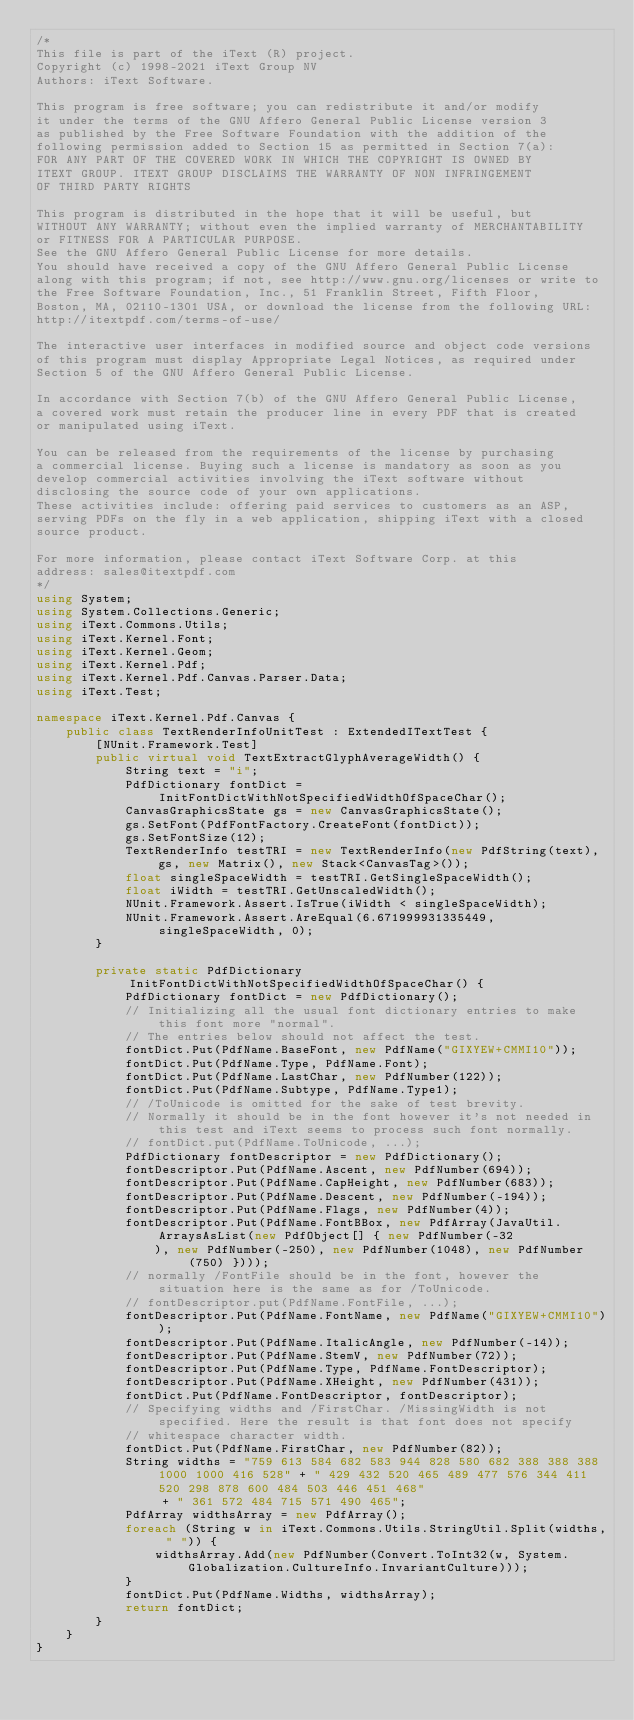<code> <loc_0><loc_0><loc_500><loc_500><_C#_>/*
This file is part of the iText (R) project.
Copyright (c) 1998-2021 iText Group NV
Authors: iText Software.

This program is free software; you can redistribute it and/or modify
it under the terms of the GNU Affero General Public License version 3
as published by the Free Software Foundation with the addition of the
following permission added to Section 15 as permitted in Section 7(a):
FOR ANY PART OF THE COVERED WORK IN WHICH THE COPYRIGHT IS OWNED BY
ITEXT GROUP. ITEXT GROUP DISCLAIMS THE WARRANTY OF NON INFRINGEMENT
OF THIRD PARTY RIGHTS

This program is distributed in the hope that it will be useful, but
WITHOUT ANY WARRANTY; without even the implied warranty of MERCHANTABILITY
or FITNESS FOR A PARTICULAR PURPOSE.
See the GNU Affero General Public License for more details.
You should have received a copy of the GNU Affero General Public License
along with this program; if not, see http://www.gnu.org/licenses or write to
the Free Software Foundation, Inc., 51 Franklin Street, Fifth Floor,
Boston, MA, 02110-1301 USA, or download the license from the following URL:
http://itextpdf.com/terms-of-use/

The interactive user interfaces in modified source and object code versions
of this program must display Appropriate Legal Notices, as required under
Section 5 of the GNU Affero General Public License.

In accordance with Section 7(b) of the GNU Affero General Public License,
a covered work must retain the producer line in every PDF that is created
or manipulated using iText.

You can be released from the requirements of the license by purchasing
a commercial license. Buying such a license is mandatory as soon as you
develop commercial activities involving the iText software without
disclosing the source code of your own applications.
These activities include: offering paid services to customers as an ASP,
serving PDFs on the fly in a web application, shipping iText with a closed
source product.

For more information, please contact iText Software Corp. at this
address: sales@itextpdf.com
*/
using System;
using System.Collections.Generic;
using iText.Commons.Utils;
using iText.Kernel.Font;
using iText.Kernel.Geom;
using iText.Kernel.Pdf;
using iText.Kernel.Pdf.Canvas.Parser.Data;
using iText.Test;

namespace iText.Kernel.Pdf.Canvas {
    public class TextRenderInfoUnitTest : ExtendedITextTest {
        [NUnit.Framework.Test]
        public virtual void TextExtractGlyphAverageWidth() {
            String text = "i";
            PdfDictionary fontDict = InitFontDictWithNotSpecifiedWidthOfSpaceChar();
            CanvasGraphicsState gs = new CanvasGraphicsState();
            gs.SetFont(PdfFontFactory.CreateFont(fontDict));
            gs.SetFontSize(12);
            TextRenderInfo testTRI = new TextRenderInfo(new PdfString(text), gs, new Matrix(), new Stack<CanvasTag>());
            float singleSpaceWidth = testTRI.GetSingleSpaceWidth();
            float iWidth = testTRI.GetUnscaledWidth();
            NUnit.Framework.Assert.IsTrue(iWidth < singleSpaceWidth);
            NUnit.Framework.Assert.AreEqual(6.671999931335449, singleSpaceWidth, 0);
        }

        private static PdfDictionary InitFontDictWithNotSpecifiedWidthOfSpaceChar() {
            PdfDictionary fontDict = new PdfDictionary();
            // Initializing all the usual font dictionary entries to make this font more "normal".
            // The entries below should not affect the test.
            fontDict.Put(PdfName.BaseFont, new PdfName("GIXYEW+CMMI10"));
            fontDict.Put(PdfName.Type, PdfName.Font);
            fontDict.Put(PdfName.LastChar, new PdfNumber(122));
            fontDict.Put(PdfName.Subtype, PdfName.Type1);
            // /ToUnicode is omitted for the sake of test brevity.
            // Normally it should be in the font however it's not needed in this test and iText seems to process such font normally.
            // fontDict.put(PdfName.ToUnicode, ...);
            PdfDictionary fontDescriptor = new PdfDictionary();
            fontDescriptor.Put(PdfName.Ascent, new PdfNumber(694));
            fontDescriptor.Put(PdfName.CapHeight, new PdfNumber(683));
            fontDescriptor.Put(PdfName.Descent, new PdfNumber(-194));
            fontDescriptor.Put(PdfName.Flags, new PdfNumber(4));
            fontDescriptor.Put(PdfName.FontBBox, new PdfArray(JavaUtil.ArraysAsList(new PdfObject[] { new PdfNumber(-32
                ), new PdfNumber(-250), new PdfNumber(1048), new PdfNumber(750) })));
            // normally /FontFile should be in the font, however the situation here is the same as for /ToUnicode.
            // fontDescriptor.put(PdfName.FontFile, ...);
            fontDescriptor.Put(PdfName.FontName, new PdfName("GIXYEW+CMMI10"));
            fontDescriptor.Put(PdfName.ItalicAngle, new PdfNumber(-14));
            fontDescriptor.Put(PdfName.StemV, new PdfNumber(72));
            fontDescriptor.Put(PdfName.Type, PdfName.FontDescriptor);
            fontDescriptor.Put(PdfName.XHeight, new PdfNumber(431));
            fontDict.Put(PdfName.FontDescriptor, fontDescriptor);
            // Specifying widths and /FirstChar. /MissingWidth is not specified. Here the result is that font does not specify
            // whitespace character width.
            fontDict.Put(PdfName.FirstChar, new PdfNumber(82));
            String widths = "759 613 584 682 583 944 828 580 682 388 388 388 1000 1000 416 528" + " 429 432 520 465 489 477 576 344 411 520 298 878 600 484 503 446 451 468"
                 + " 361 572 484 715 571 490 465";
            PdfArray widthsArray = new PdfArray();
            foreach (String w in iText.Commons.Utils.StringUtil.Split(widths, " ")) {
                widthsArray.Add(new PdfNumber(Convert.ToInt32(w, System.Globalization.CultureInfo.InvariantCulture)));
            }
            fontDict.Put(PdfName.Widths, widthsArray);
            return fontDict;
        }
    }
}
</code> 